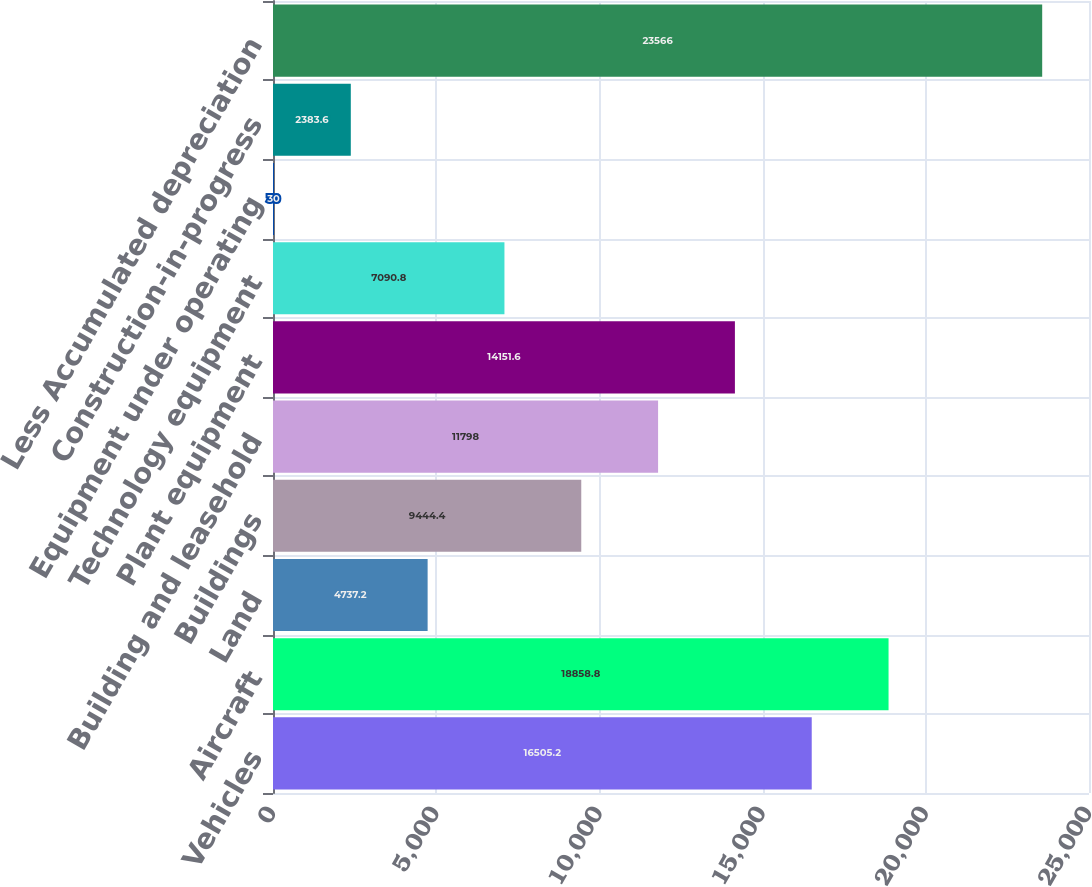<chart> <loc_0><loc_0><loc_500><loc_500><bar_chart><fcel>Vehicles<fcel>Aircraft<fcel>Land<fcel>Buildings<fcel>Building and leasehold<fcel>Plant equipment<fcel>Technology equipment<fcel>Equipment under operating<fcel>Construction-in-progress<fcel>Less Accumulated depreciation<nl><fcel>16505.2<fcel>18858.8<fcel>4737.2<fcel>9444.4<fcel>11798<fcel>14151.6<fcel>7090.8<fcel>30<fcel>2383.6<fcel>23566<nl></chart> 